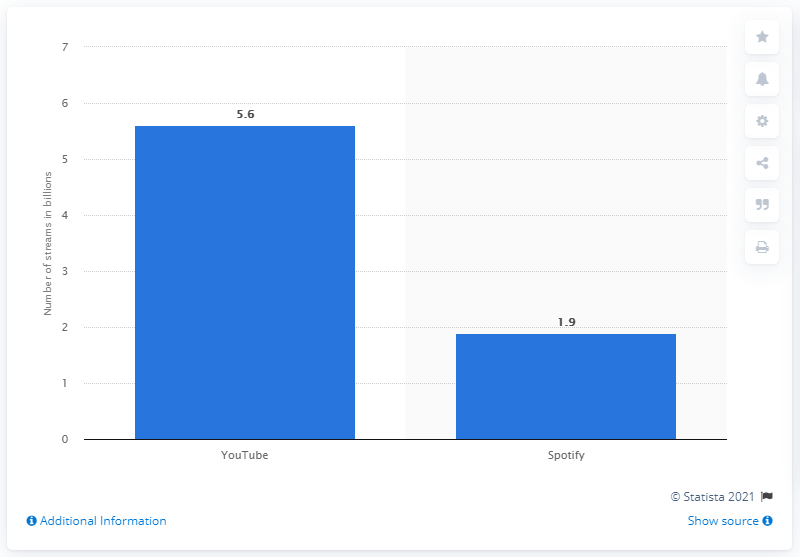Specify some key components in this picture. Spotify has reported that 'Despacito' has been streamed a total of 1,900 times. As of April 2018, Luis Fonsi's video had 5.6 million views on YouTube. 